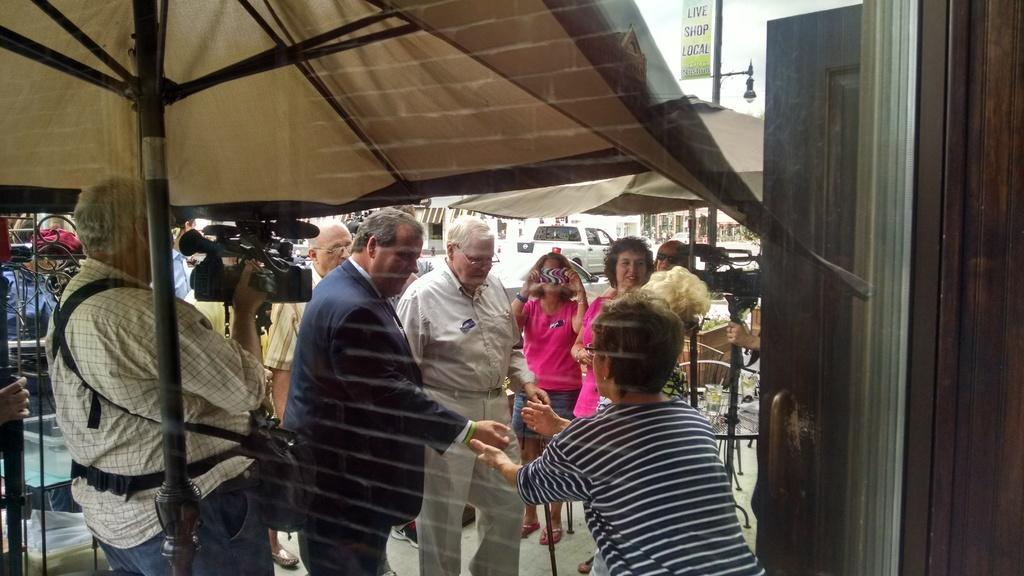Could you give a brief overview of what you see in this image? In this image we can see a glass and through the glass we can see few persons are standing and a person is holding a camera in the hands and carrying a bag on the shoulders and we can see umbrellas, metal objects, board and light on a pole, vehicle and objects. 